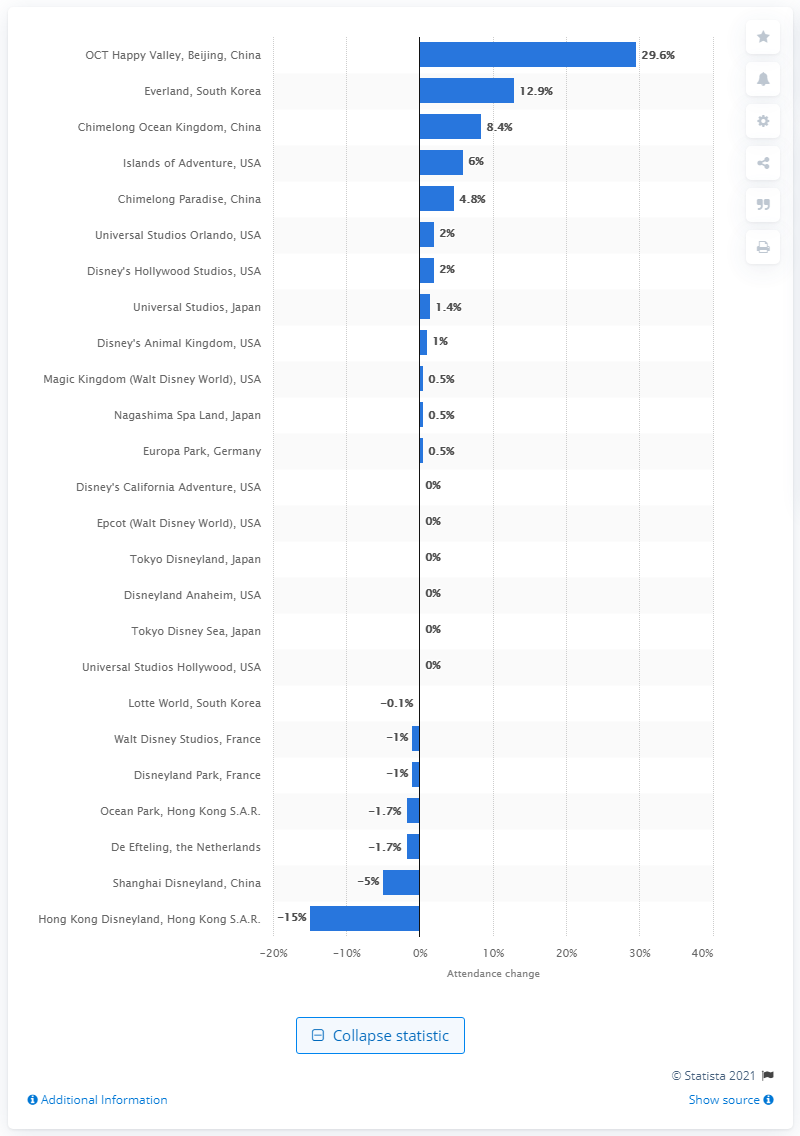Point out several critical features in this image. The attendance of OCT Happy Valley increased by 29.6% from 2018 to 2019. 